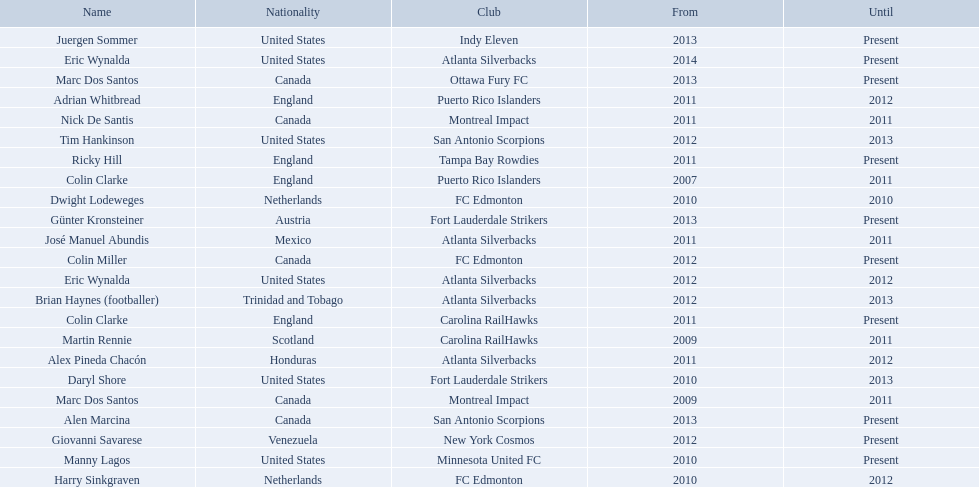What year did marc dos santos start as coach? 2009. Besides marc dos santos, what other coach started in 2009? Martin Rennie. 